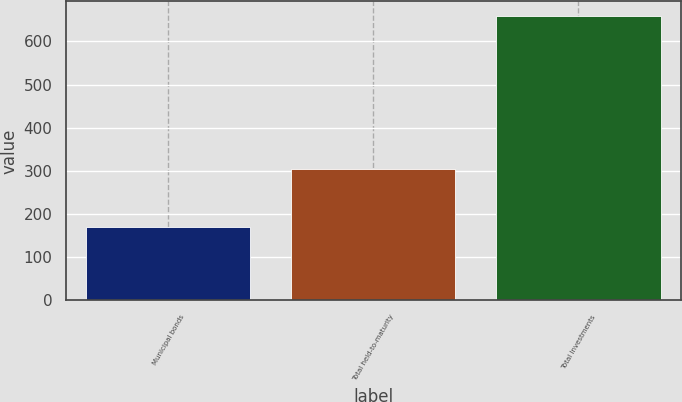<chart> <loc_0><loc_0><loc_500><loc_500><bar_chart><fcel>Municipal bonds<fcel>Total held-to-maturity<fcel>Total Investments<nl><fcel>170<fcel>303.6<fcel>659.6<nl></chart> 